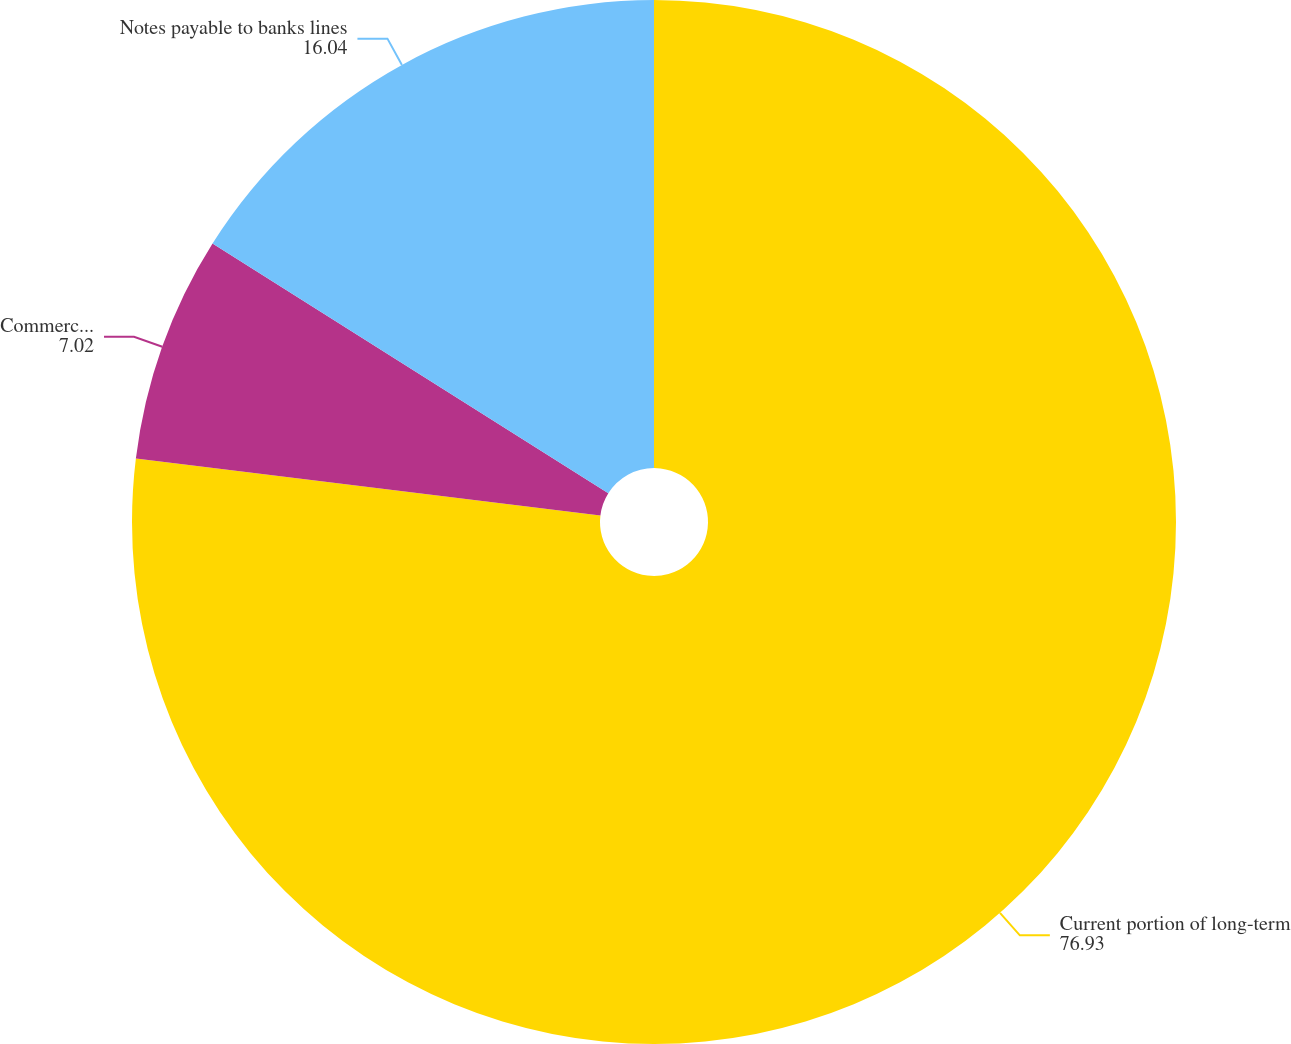<chart> <loc_0><loc_0><loc_500><loc_500><pie_chart><fcel>Current portion of long-term<fcel>Commercial paper<fcel>Notes payable to banks lines<nl><fcel>76.93%<fcel>7.02%<fcel>16.04%<nl></chart> 